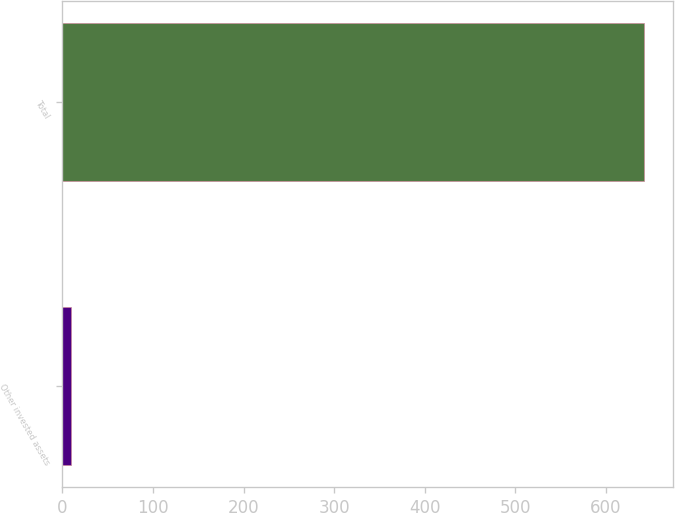<chart> <loc_0><loc_0><loc_500><loc_500><bar_chart><fcel>Other invested assets<fcel>Total<nl><fcel>10<fcel>642<nl></chart> 